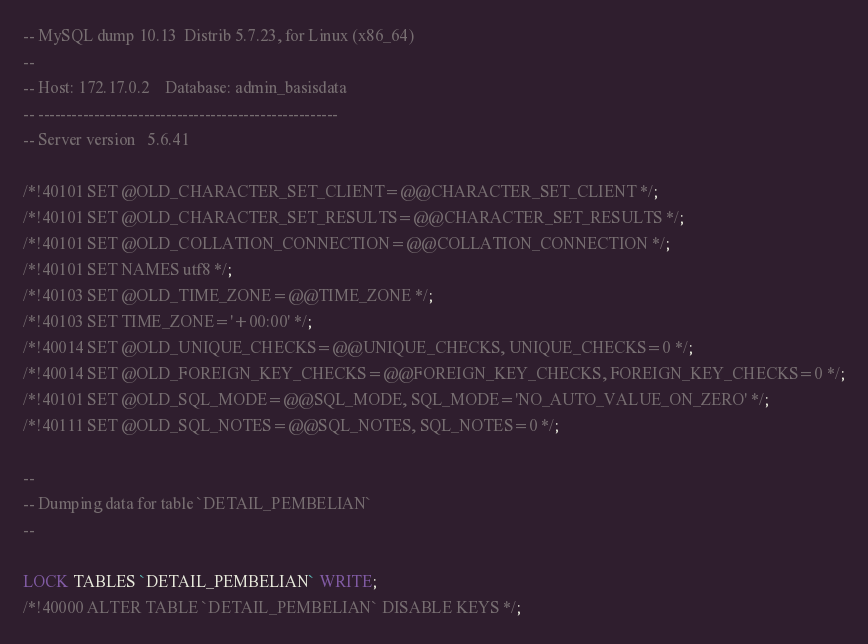Convert code to text. <code><loc_0><loc_0><loc_500><loc_500><_SQL_>-- MySQL dump 10.13  Distrib 5.7.23, for Linux (x86_64)
--
-- Host: 172.17.0.2    Database: admin_basisdata
-- ------------------------------------------------------
-- Server version	5.6.41

/*!40101 SET @OLD_CHARACTER_SET_CLIENT=@@CHARACTER_SET_CLIENT */;
/*!40101 SET @OLD_CHARACTER_SET_RESULTS=@@CHARACTER_SET_RESULTS */;
/*!40101 SET @OLD_COLLATION_CONNECTION=@@COLLATION_CONNECTION */;
/*!40101 SET NAMES utf8 */;
/*!40103 SET @OLD_TIME_ZONE=@@TIME_ZONE */;
/*!40103 SET TIME_ZONE='+00:00' */;
/*!40014 SET @OLD_UNIQUE_CHECKS=@@UNIQUE_CHECKS, UNIQUE_CHECKS=0 */;
/*!40014 SET @OLD_FOREIGN_KEY_CHECKS=@@FOREIGN_KEY_CHECKS, FOREIGN_KEY_CHECKS=0 */;
/*!40101 SET @OLD_SQL_MODE=@@SQL_MODE, SQL_MODE='NO_AUTO_VALUE_ON_ZERO' */;
/*!40111 SET @OLD_SQL_NOTES=@@SQL_NOTES, SQL_NOTES=0 */;

--
-- Dumping data for table `DETAIL_PEMBELIAN`
--

LOCK TABLES `DETAIL_PEMBELIAN` WRITE;
/*!40000 ALTER TABLE `DETAIL_PEMBELIAN` DISABLE KEYS */;</code> 